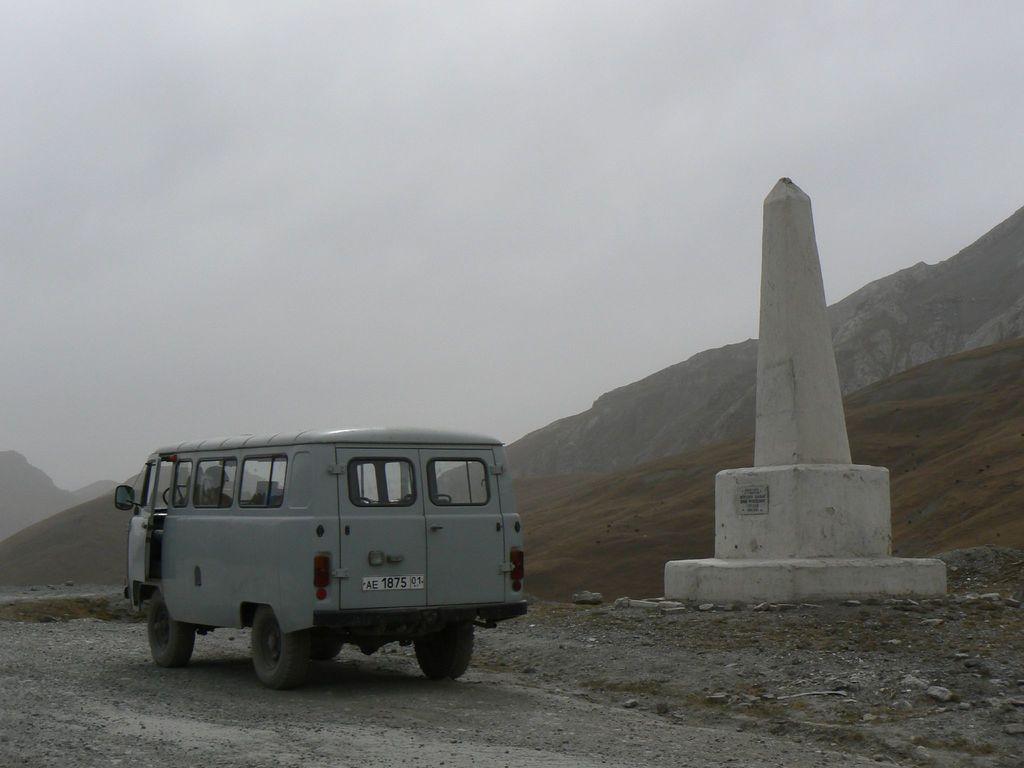Describe this image in one or two sentences. In this image there is a van on a road, beside the van there is pillar, in the background there is a mountain and the sky. 